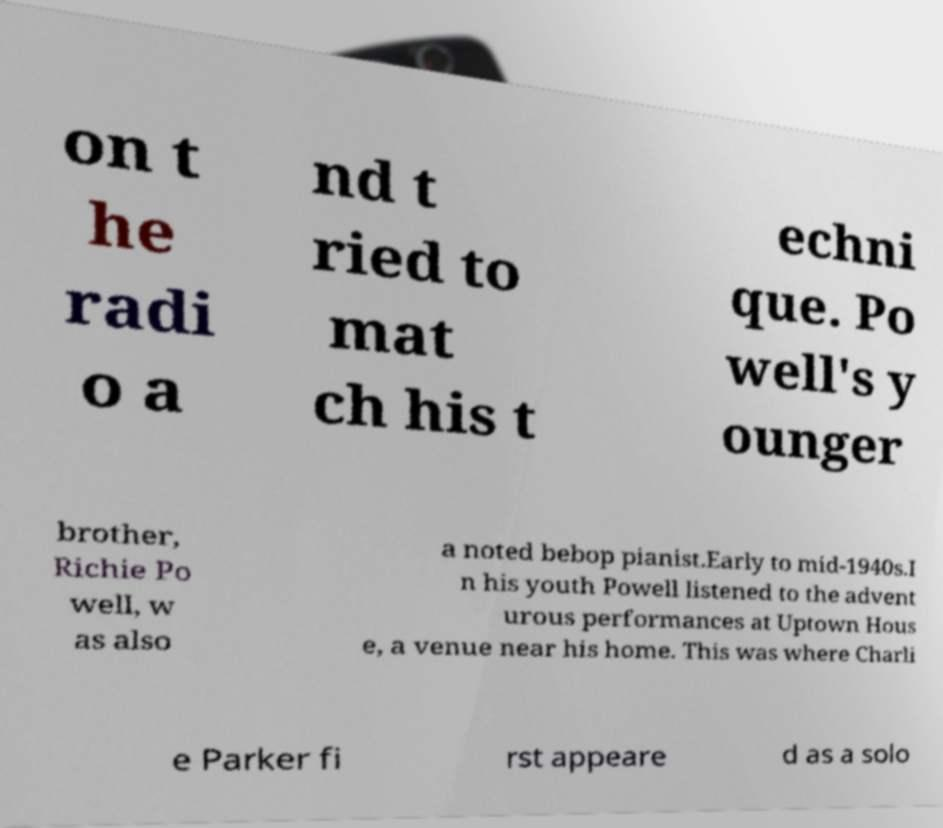There's text embedded in this image that I need extracted. Can you transcribe it verbatim? on t he radi o a nd t ried to mat ch his t echni que. Po well's y ounger brother, Richie Po well, w as also a noted bebop pianist.Early to mid-1940s.I n his youth Powell listened to the advent urous performances at Uptown Hous e, a venue near his home. This was where Charli e Parker fi rst appeare d as a solo 